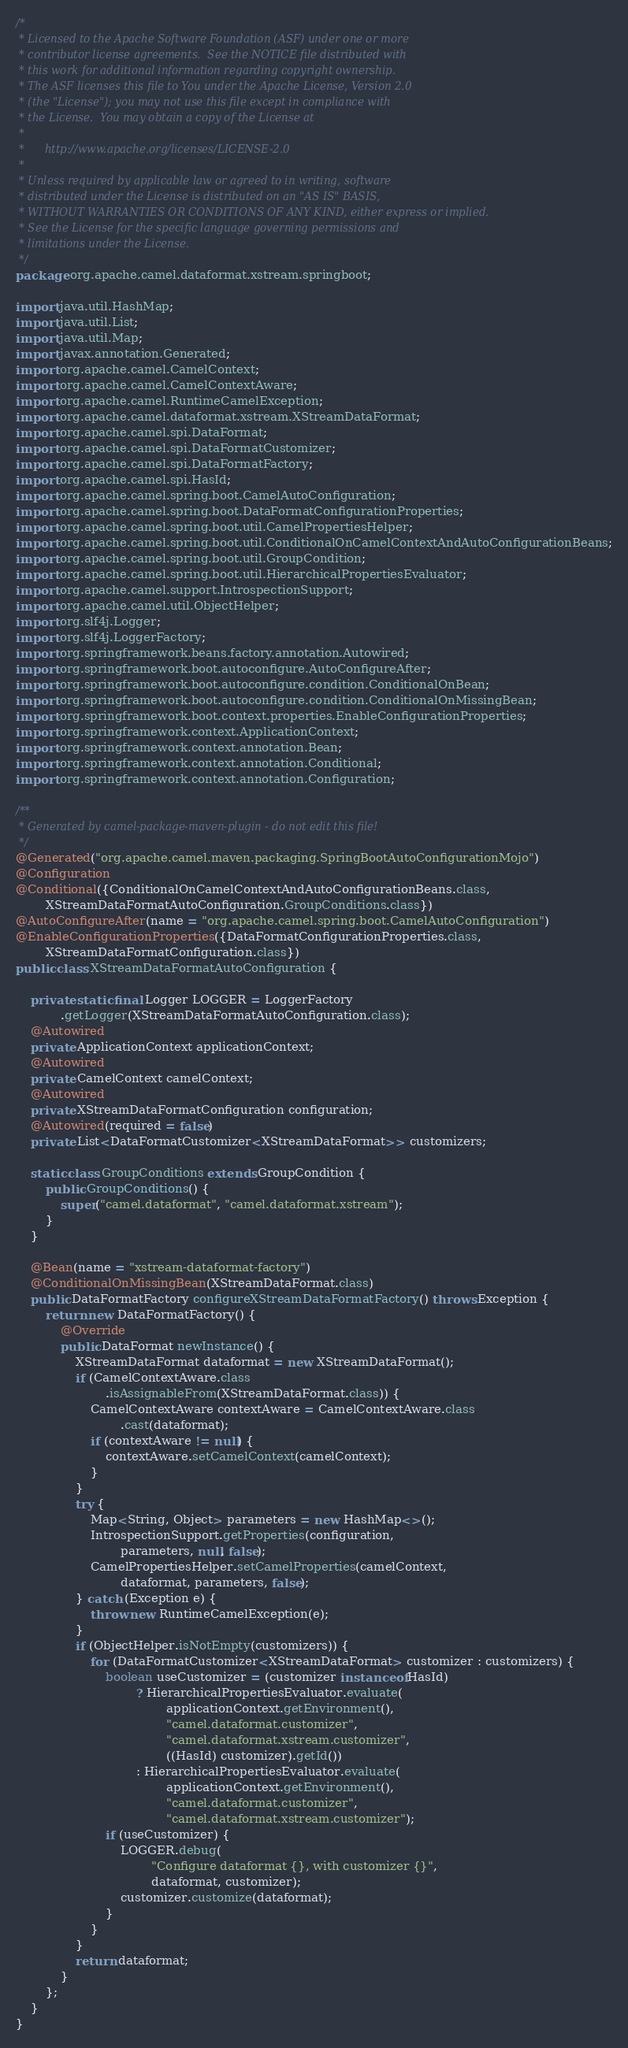Convert code to text. <code><loc_0><loc_0><loc_500><loc_500><_Java_>/*
 * Licensed to the Apache Software Foundation (ASF) under one or more
 * contributor license agreements.  See the NOTICE file distributed with
 * this work for additional information regarding copyright ownership.
 * The ASF licenses this file to You under the Apache License, Version 2.0
 * (the "License"); you may not use this file except in compliance with
 * the License.  You may obtain a copy of the License at
 *
 *      http://www.apache.org/licenses/LICENSE-2.0
 *
 * Unless required by applicable law or agreed to in writing, software
 * distributed under the License is distributed on an "AS IS" BASIS,
 * WITHOUT WARRANTIES OR CONDITIONS OF ANY KIND, either express or implied.
 * See the License for the specific language governing permissions and
 * limitations under the License.
 */
package org.apache.camel.dataformat.xstream.springboot;

import java.util.HashMap;
import java.util.List;
import java.util.Map;
import javax.annotation.Generated;
import org.apache.camel.CamelContext;
import org.apache.camel.CamelContextAware;
import org.apache.camel.RuntimeCamelException;
import org.apache.camel.dataformat.xstream.XStreamDataFormat;
import org.apache.camel.spi.DataFormat;
import org.apache.camel.spi.DataFormatCustomizer;
import org.apache.camel.spi.DataFormatFactory;
import org.apache.camel.spi.HasId;
import org.apache.camel.spring.boot.CamelAutoConfiguration;
import org.apache.camel.spring.boot.DataFormatConfigurationProperties;
import org.apache.camel.spring.boot.util.CamelPropertiesHelper;
import org.apache.camel.spring.boot.util.ConditionalOnCamelContextAndAutoConfigurationBeans;
import org.apache.camel.spring.boot.util.GroupCondition;
import org.apache.camel.spring.boot.util.HierarchicalPropertiesEvaluator;
import org.apache.camel.support.IntrospectionSupport;
import org.apache.camel.util.ObjectHelper;
import org.slf4j.Logger;
import org.slf4j.LoggerFactory;
import org.springframework.beans.factory.annotation.Autowired;
import org.springframework.boot.autoconfigure.AutoConfigureAfter;
import org.springframework.boot.autoconfigure.condition.ConditionalOnBean;
import org.springframework.boot.autoconfigure.condition.ConditionalOnMissingBean;
import org.springframework.boot.context.properties.EnableConfigurationProperties;
import org.springframework.context.ApplicationContext;
import org.springframework.context.annotation.Bean;
import org.springframework.context.annotation.Conditional;
import org.springframework.context.annotation.Configuration;

/**
 * Generated by camel-package-maven-plugin - do not edit this file!
 */
@Generated("org.apache.camel.maven.packaging.SpringBootAutoConfigurationMojo")
@Configuration
@Conditional({ConditionalOnCamelContextAndAutoConfigurationBeans.class,
        XStreamDataFormatAutoConfiguration.GroupConditions.class})
@AutoConfigureAfter(name = "org.apache.camel.spring.boot.CamelAutoConfiguration")
@EnableConfigurationProperties({DataFormatConfigurationProperties.class,
        XStreamDataFormatConfiguration.class})
public class XStreamDataFormatAutoConfiguration {

    private static final Logger LOGGER = LoggerFactory
            .getLogger(XStreamDataFormatAutoConfiguration.class);
    @Autowired
    private ApplicationContext applicationContext;
    @Autowired
    private CamelContext camelContext;
    @Autowired
    private XStreamDataFormatConfiguration configuration;
    @Autowired(required = false)
    private List<DataFormatCustomizer<XStreamDataFormat>> customizers;

    static class GroupConditions extends GroupCondition {
        public GroupConditions() {
            super("camel.dataformat", "camel.dataformat.xstream");
        }
    }

    @Bean(name = "xstream-dataformat-factory")
    @ConditionalOnMissingBean(XStreamDataFormat.class)
    public DataFormatFactory configureXStreamDataFormatFactory() throws Exception {
        return new DataFormatFactory() {
            @Override
            public DataFormat newInstance() {
                XStreamDataFormat dataformat = new XStreamDataFormat();
                if (CamelContextAware.class
                        .isAssignableFrom(XStreamDataFormat.class)) {
                    CamelContextAware contextAware = CamelContextAware.class
                            .cast(dataformat);
                    if (contextAware != null) {
                        contextAware.setCamelContext(camelContext);
                    }
                }
                try {
                    Map<String, Object> parameters = new HashMap<>();
                    IntrospectionSupport.getProperties(configuration,
                            parameters, null, false);
                    CamelPropertiesHelper.setCamelProperties(camelContext,
                            dataformat, parameters, false);
                } catch (Exception e) {
                    throw new RuntimeCamelException(e);
                }
                if (ObjectHelper.isNotEmpty(customizers)) {
                    for (DataFormatCustomizer<XStreamDataFormat> customizer : customizers) {
                        boolean useCustomizer = (customizer instanceof HasId)
                                ? HierarchicalPropertiesEvaluator.evaluate(
                                        applicationContext.getEnvironment(),
                                        "camel.dataformat.customizer",
                                        "camel.dataformat.xstream.customizer",
                                        ((HasId) customizer).getId())
                                : HierarchicalPropertiesEvaluator.evaluate(
                                        applicationContext.getEnvironment(),
                                        "camel.dataformat.customizer",
                                        "camel.dataformat.xstream.customizer");
                        if (useCustomizer) {
                            LOGGER.debug(
                                    "Configure dataformat {}, with customizer {}",
                                    dataformat, customizer);
                            customizer.customize(dataformat);
                        }
                    }
                }
                return dataformat;
            }
        };
    }
}</code> 